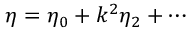<formula> <loc_0><loc_0><loc_500><loc_500>\eta = \eta _ { 0 } + k ^ { 2 } \eta _ { 2 } + \cdots</formula> 